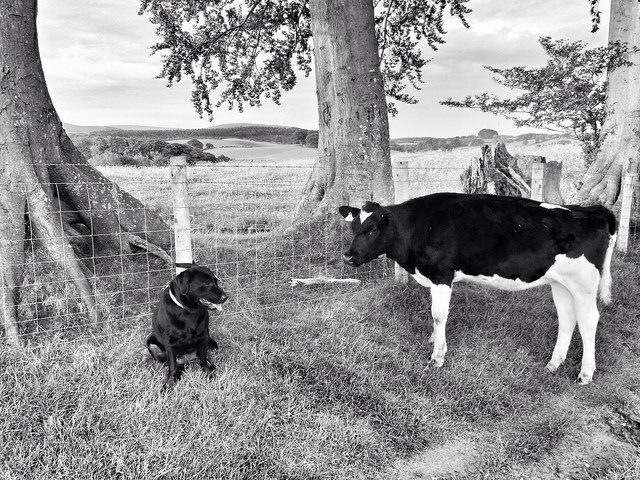Describe the objects in this image and their specific colors. I can see cow in gray, black, white, and darkgray tones and dog in gray, black, and darkgray tones in this image. 